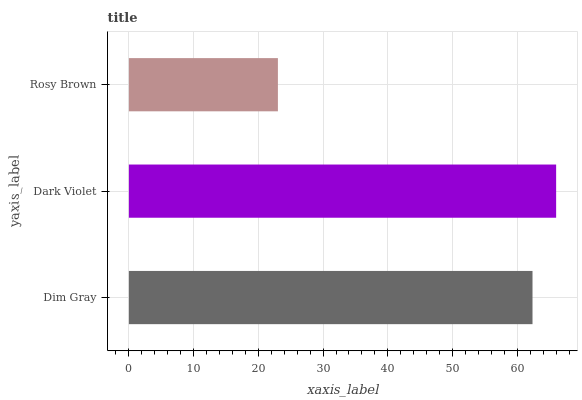Is Rosy Brown the minimum?
Answer yes or no. Yes. Is Dark Violet the maximum?
Answer yes or no. Yes. Is Dark Violet the minimum?
Answer yes or no. No. Is Rosy Brown the maximum?
Answer yes or no. No. Is Dark Violet greater than Rosy Brown?
Answer yes or no. Yes. Is Rosy Brown less than Dark Violet?
Answer yes or no. Yes. Is Rosy Brown greater than Dark Violet?
Answer yes or no. No. Is Dark Violet less than Rosy Brown?
Answer yes or no. No. Is Dim Gray the high median?
Answer yes or no. Yes. Is Dim Gray the low median?
Answer yes or no. Yes. Is Rosy Brown the high median?
Answer yes or no. No. Is Dark Violet the low median?
Answer yes or no. No. 